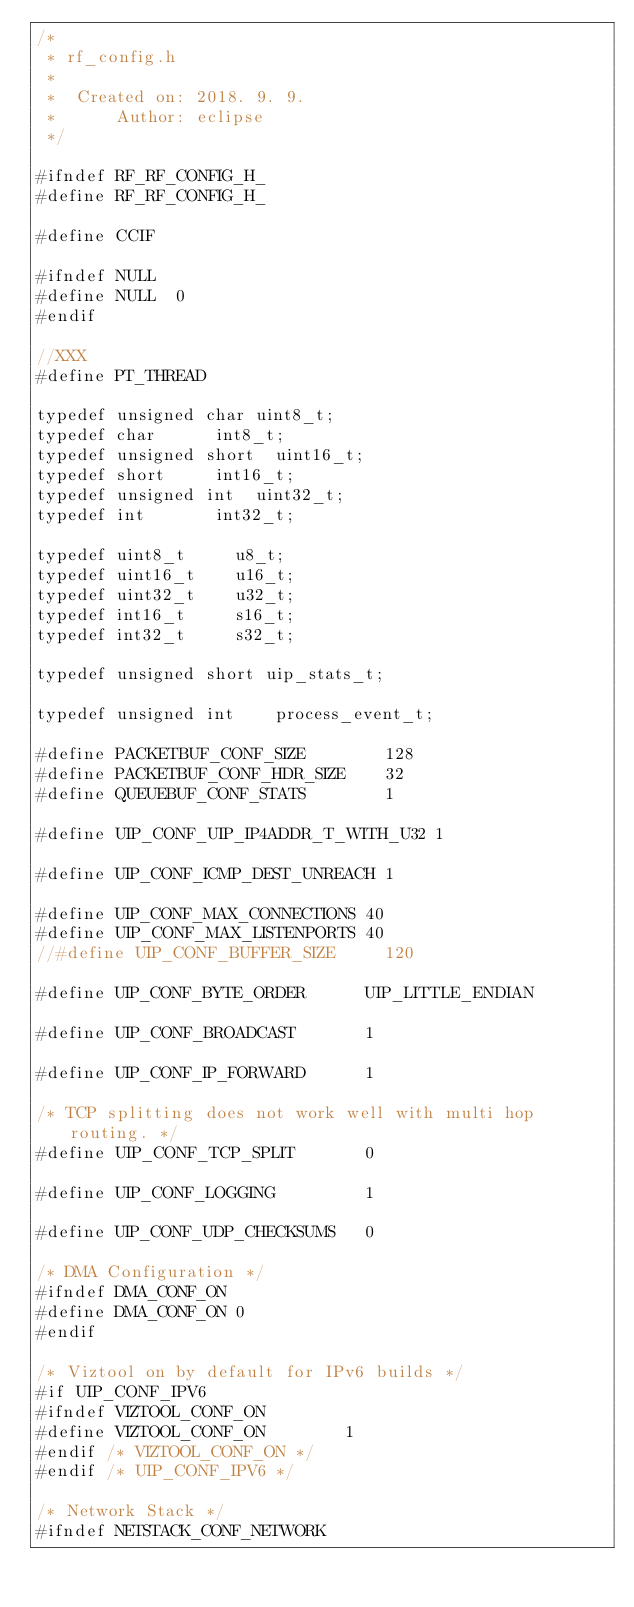Convert code to text. <code><loc_0><loc_0><loc_500><loc_500><_C_>/*
 * rf_config.h
 *
 *  Created on: 2018. 9. 9.
 *      Author: eclipse
 */

#ifndef RF_RF_CONFIG_H_
#define RF_RF_CONFIG_H_

#define CCIF

#ifndef NULL
#define NULL	0
#endif

//XXX
#define PT_THREAD

typedef	unsigned char	uint8_t;
typedef char			int8_t;
typedef unsigned short	uint16_t;
typedef short			int16_t;
typedef unsigned int	uint32_t;
typedef int				int32_t;

typedef uint8_t 		u8_t;
typedef uint16_t		u16_t;
typedef uint32_t 		u32_t;
typedef int16_t			s16_t;
typedef int32_t 		s32_t;

typedef unsigned short uip_stats_t;

typedef unsigned int  	process_event_t;

#define PACKETBUF_CONF_SIZE        128
#define PACKETBUF_CONF_HDR_SIZE    32
#define QUEUEBUF_CONF_STATS        1

#define UIP_CONF_UIP_IP4ADDR_T_WITH_U32 1

#define UIP_CONF_ICMP_DEST_UNREACH 1

#define UIP_CONF_MAX_CONNECTIONS 40
#define UIP_CONF_MAX_LISTENPORTS 40
//#define UIP_CONF_BUFFER_SIZE     120

#define UIP_CONF_BYTE_ORDER      UIP_LITTLE_ENDIAN

#define UIP_CONF_BROADCAST       1

#define UIP_CONF_IP_FORWARD      1

/* TCP splitting does not work well with multi hop routing. */
#define UIP_CONF_TCP_SPLIT       0

#define UIP_CONF_LOGGING         1

#define UIP_CONF_UDP_CHECKSUMS   0

/* DMA Configuration */
#ifndef DMA_CONF_ON
#define DMA_CONF_ON 0
#endif

/* Viztool on by default for IPv6 builds */
#if UIP_CONF_IPV6
#ifndef VIZTOOL_CONF_ON
#define VIZTOOL_CONF_ON        1
#endif /* VIZTOOL_CONF_ON */
#endif /* UIP_CONF_IPV6 */

/* Network Stack */
#ifndef NETSTACK_CONF_NETWORK</code> 